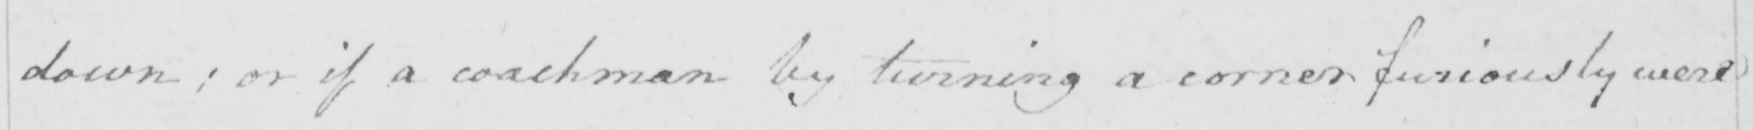Can you read and transcribe this handwriting? down ; or if a coachman by turning a corner furiously were 